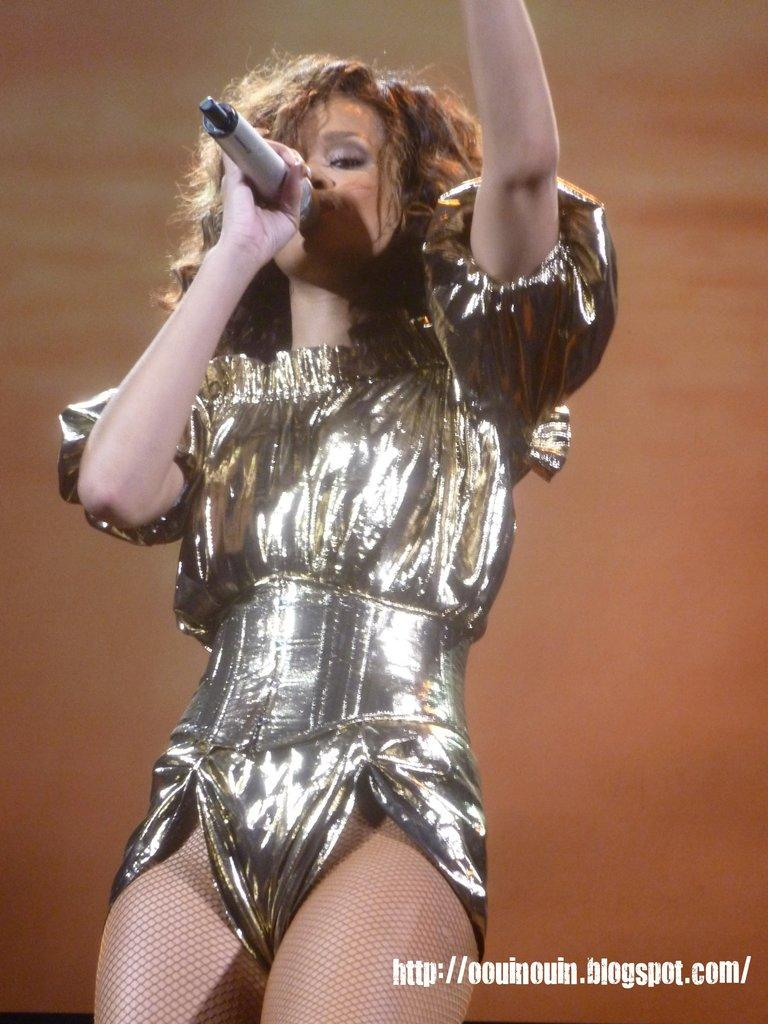Who is the main subject in the image? There is a woman in the image. What is the woman holding in her hand? The woman is holding a microphone in her hand. What else is the woman holding? The woman is also holding a text. What is the color of the background in the image? The background color is brown. Where might this image have been taken? The image may have been taken on a stage, given the presence of a microphone and the possibility of a performance. Reasoning: Let's think step by following the steps to produce the conversation. We start by identifying the main subject in the image, which is the woman. Then, we describe the objects she is holding, which are a microphone and a text. Next, we mention the background color, which is brown. Finally, we speculate on the possible location of the image, which might be a stage. Each question is designed to elicit a specific detail about the image that is known from the provided facts. Absurd Question/Answer: What type of pear is the woman eating in the image? There is no pear present in the image; the woman is holding a microphone and a text. 